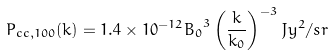Convert formula to latex. <formula><loc_0><loc_0><loc_500><loc_500>P _ { c c , 1 0 0 } ( k ) = 1 . 4 \times 1 0 ^ { - 1 2 } { B _ { 0 } } ^ { 3 } \left ( \frac { k } { k _ { 0 } } \right ) ^ { - 3 } J y ^ { 2 } / s r</formula> 